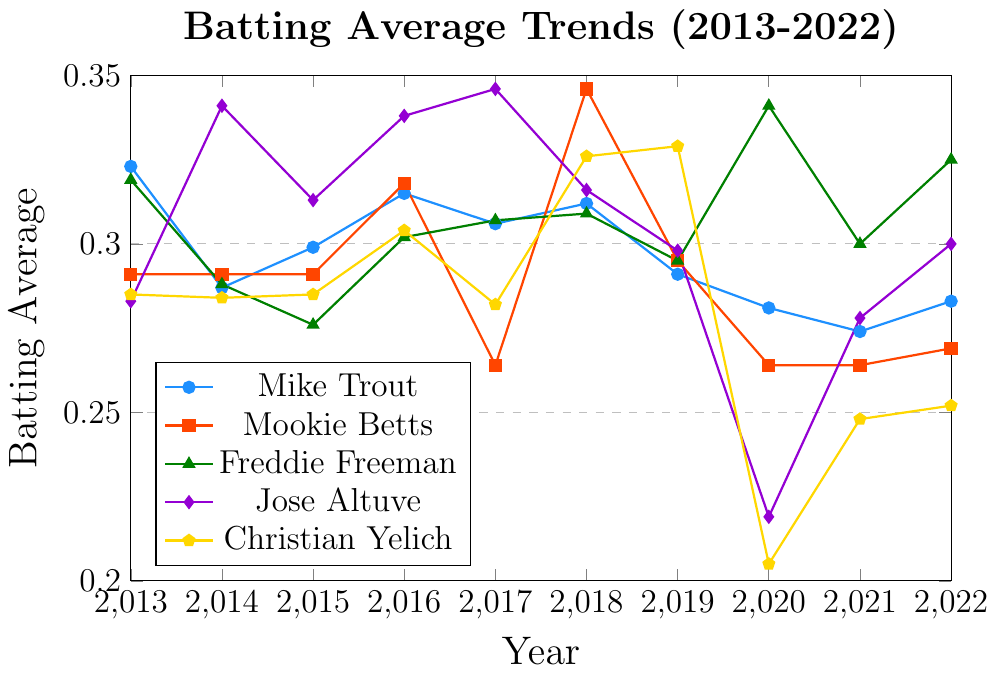What's the average batting average of Mike Trout from 2013 to 2022? To find the average batting average, sum up all the yearly averages and then divide by the number of years. Trout's averages are: 0.323, 0.287, 0.299, 0.315, 0.306, 0.312, 0.291, 0.281, 0.274, and 0.283. Summing these gives 2.971, and dividing by 10 gives 0.2971.
Answer: 0.297 Which player had the lowest batting average in 2020? Look at the batting averages for all players in 2020: Mike Trout (0.281), Mookie Betts (0.264), Freddie Freeman (0.341), Jose Altuve (0.219), and Christian Yelich (0.205). The lowest value is 0.205.
Answer: Christian Yelich Did any player’s batting average remain the same for at least two consecutive years? Check if any player's averages are the same for two consecutive years. Mookie Betts had 0.291 from 2013 to 2015 and 0.264 from 2019 to 2021.
Answer: Mookie Betts Whose batting average increased the most between any two consecutive years? Calculate the difference in batting averages for consecutive years for each player. The largest increase is Freddie Freeman from 2019 (0.295) to 2020 (0.341), which is 0.046.
Answer: Freddie Freeman Between 2018 and 2020, which player's batting average had the greatest percentage decrease? Calculate the percentage decrease for each player from 2018 to 2020. Percent decrease = (initial - final) / initial. Mike Trout: (0.312 - 0.281) / 0.312 = 0.099, Mookie Betts: (0.346 - 0.264) / 0.346 = 0.237, Freddie Freeman: (0.309 - 0.341) / 0.309 = -0.103, Jose Altuve: (0.316 - 0.219) / 0.316 = 0.307, Christian Yelich: (0.326 - 0.205) / 0.326 = 0.371. Yelich had the greatest percentage decrease.
Answer: Christian Yelich Which player's batting average showed the most consistency over the 10-year period? Consistency can be measured by the smallest variance in batting averages. Calculate variance for each player (you can visually see this without detailed calculations). Mookie Betts' averages vary the least around the mean compared to other players.
Answer: Mookie Betts In which year did the highest batting average occur among all players? Look at the highest batting average for each year and compare. The highest is 0.346, occurring in 2014 (Jose Altuve) and 2018 (Mookie Betts).
Answer: 2014, 2018 What is the difference between Mike Trout's highest and lowest batting averages over the period? Identify Mike Trout's highest (0.323 in 2013) and lowest (0.274 in 2021) averages. The difference is 0.323 - 0.274 = 0.049.
Answer: 0.049 Compare the trends of Freddie Freeman and Jose Altuve from 2013 to 2022. Who shows a more stable performance? Stable performance can be interpreted as less fluctuation. Freeman's trend is relatively smooth compared to Altuve's, which shows more dramatic changes especially the drop to 0.219 in 2020.
Answer: Freddie Freeman 